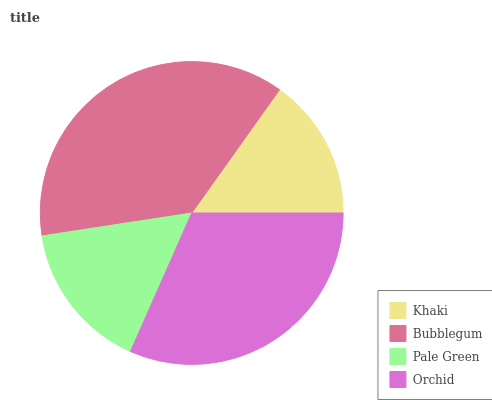Is Khaki the minimum?
Answer yes or no. Yes. Is Bubblegum the maximum?
Answer yes or no. Yes. Is Pale Green the minimum?
Answer yes or no. No. Is Pale Green the maximum?
Answer yes or no. No. Is Bubblegum greater than Pale Green?
Answer yes or no. Yes. Is Pale Green less than Bubblegum?
Answer yes or no. Yes. Is Pale Green greater than Bubblegum?
Answer yes or no. No. Is Bubblegum less than Pale Green?
Answer yes or no. No. Is Orchid the high median?
Answer yes or no. Yes. Is Pale Green the low median?
Answer yes or no. Yes. Is Khaki the high median?
Answer yes or no. No. Is Bubblegum the low median?
Answer yes or no. No. 